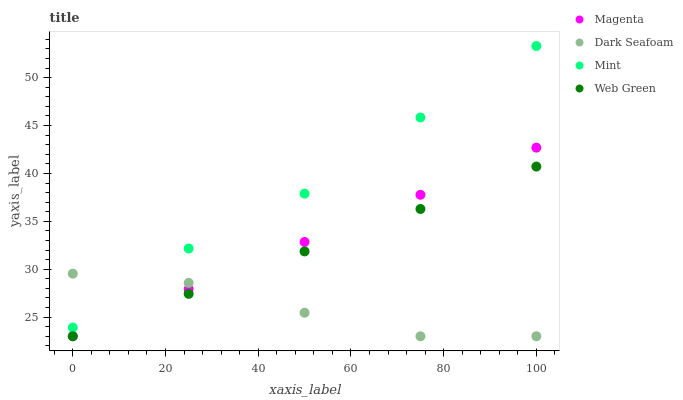Does Dark Seafoam have the minimum area under the curve?
Answer yes or no. Yes. Does Mint have the maximum area under the curve?
Answer yes or no. Yes. Does Mint have the minimum area under the curve?
Answer yes or no. No. Does Dark Seafoam have the maximum area under the curve?
Answer yes or no. No. Is Web Green the smoothest?
Answer yes or no. Yes. Is Dark Seafoam the roughest?
Answer yes or no. Yes. Is Mint the smoothest?
Answer yes or no. No. Is Mint the roughest?
Answer yes or no. No. Does Magenta have the lowest value?
Answer yes or no. Yes. Does Mint have the lowest value?
Answer yes or no. No. Does Mint have the highest value?
Answer yes or no. Yes. Does Dark Seafoam have the highest value?
Answer yes or no. No. Is Magenta less than Mint?
Answer yes or no. Yes. Is Mint greater than Magenta?
Answer yes or no. Yes. Does Web Green intersect Magenta?
Answer yes or no. Yes. Is Web Green less than Magenta?
Answer yes or no. No. Is Web Green greater than Magenta?
Answer yes or no. No. Does Magenta intersect Mint?
Answer yes or no. No. 